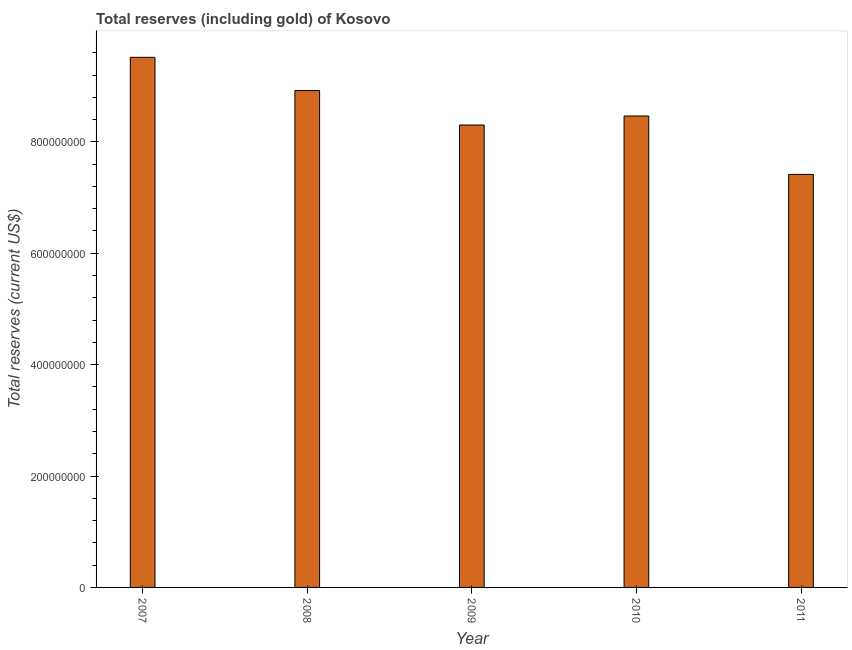Does the graph contain grids?
Your answer should be very brief. No. What is the title of the graph?
Offer a very short reply. Total reserves (including gold) of Kosovo. What is the label or title of the X-axis?
Your answer should be very brief. Year. What is the label or title of the Y-axis?
Ensure brevity in your answer.  Total reserves (current US$). What is the total reserves (including gold) in 2008?
Give a very brief answer. 8.92e+08. Across all years, what is the maximum total reserves (including gold)?
Your answer should be very brief. 9.52e+08. Across all years, what is the minimum total reserves (including gold)?
Give a very brief answer. 7.42e+08. What is the sum of the total reserves (including gold)?
Your answer should be very brief. 4.26e+09. What is the difference between the total reserves (including gold) in 2010 and 2011?
Ensure brevity in your answer.  1.05e+08. What is the average total reserves (including gold) per year?
Make the answer very short. 8.52e+08. What is the median total reserves (including gold)?
Offer a terse response. 8.46e+08. In how many years, is the total reserves (including gold) greater than 440000000 US$?
Your answer should be compact. 5. What is the ratio of the total reserves (including gold) in 2009 to that in 2010?
Give a very brief answer. 0.98. Is the total reserves (including gold) in 2008 less than that in 2011?
Provide a succinct answer. No. What is the difference between the highest and the second highest total reserves (including gold)?
Your response must be concise. 5.97e+07. Is the sum of the total reserves (including gold) in 2008 and 2010 greater than the maximum total reserves (including gold) across all years?
Your response must be concise. Yes. What is the difference between the highest and the lowest total reserves (including gold)?
Offer a terse response. 2.10e+08. Are all the bars in the graph horizontal?
Provide a short and direct response. No. Are the values on the major ticks of Y-axis written in scientific E-notation?
Keep it short and to the point. No. What is the Total reserves (current US$) in 2007?
Make the answer very short. 9.52e+08. What is the Total reserves (current US$) of 2008?
Provide a succinct answer. 8.92e+08. What is the Total reserves (current US$) in 2009?
Your answer should be very brief. 8.30e+08. What is the Total reserves (current US$) of 2010?
Your answer should be very brief. 8.46e+08. What is the Total reserves (current US$) in 2011?
Offer a terse response. 7.42e+08. What is the difference between the Total reserves (current US$) in 2007 and 2008?
Your answer should be very brief. 5.97e+07. What is the difference between the Total reserves (current US$) in 2007 and 2009?
Your answer should be compact. 1.22e+08. What is the difference between the Total reserves (current US$) in 2007 and 2010?
Provide a succinct answer. 1.05e+08. What is the difference between the Total reserves (current US$) in 2007 and 2011?
Your response must be concise. 2.10e+08. What is the difference between the Total reserves (current US$) in 2008 and 2009?
Your answer should be compact. 6.19e+07. What is the difference between the Total reserves (current US$) in 2008 and 2010?
Your answer should be very brief. 4.57e+07. What is the difference between the Total reserves (current US$) in 2008 and 2011?
Make the answer very short. 1.51e+08. What is the difference between the Total reserves (current US$) in 2009 and 2010?
Offer a terse response. -1.62e+07. What is the difference between the Total reserves (current US$) in 2009 and 2011?
Offer a terse response. 8.87e+07. What is the difference between the Total reserves (current US$) in 2010 and 2011?
Offer a terse response. 1.05e+08. What is the ratio of the Total reserves (current US$) in 2007 to that in 2008?
Your answer should be very brief. 1.07. What is the ratio of the Total reserves (current US$) in 2007 to that in 2009?
Offer a very short reply. 1.15. What is the ratio of the Total reserves (current US$) in 2007 to that in 2010?
Provide a short and direct response. 1.12. What is the ratio of the Total reserves (current US$) in 2007 to that in 2011?
Offer a terse response. 1.28. What is the ratio of the Total reserves (current US$) in 2008 to that in 2009?
Provide a short and direct response. 1.07. What is the ratio of the Total reserves (current US$) in 2008 to that in 2010?
Provide a short and direct response. 1.05. What is the ratio of the Total reserves (current US$) in 2008 to that in 2011?
Your answer should be compact. 1.2. What is the ratio of the Total reserves (current US$) in 2009 to that in 2011?
Ensure brevity in your answer.  1.12. What is the ratio of the Total reserves (current US$) in 2010 to that in 2011?
Ensure brevity in your answer.  1.14. 